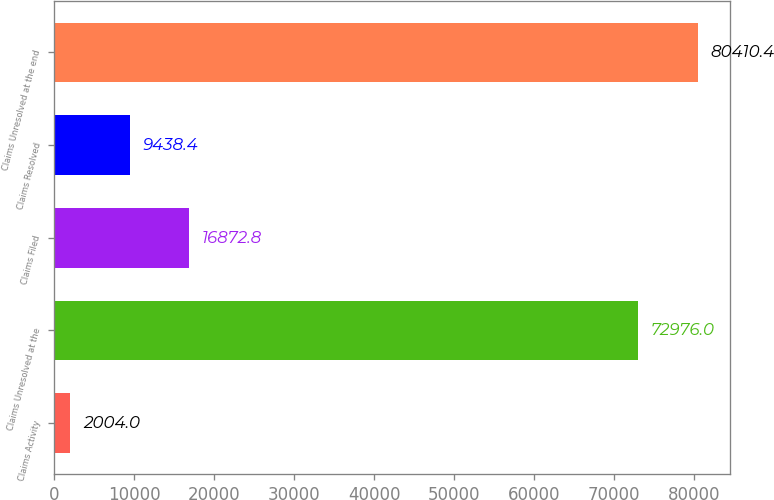Convert chart to OTSL. <chart><loc_0><loc_0><loc_500><loc_500><bar_chart><fcel>Claims Activity<fcel>Claims Unresolved at the<fcel>Claims Filed<fcel>Claims Resolved<fcel>Claims Unresolved at the end<nl><fcel>2004<fcel>72976<fcel>16872.8<fcel>9438.4<fcel>80410.4<nl></chart> 